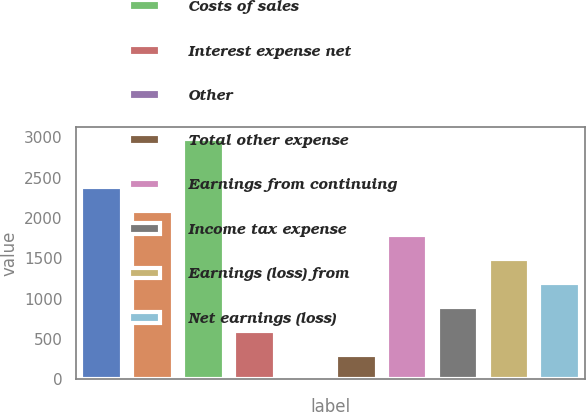Convert chart. <chart><loc_0><loc_0><loc_500><loc_500><bar_chart><fcel>Costs of product sales<fcel>Costs of services sales<fcel>Costs of sales<fcel>Interest expense net<fcel>Other<fcel>Total other expense<fcel>Earnings from continuing<fcel>Income tax expense<fcel>Earnings (loss) from<fcel>Net earnings (loss)<nl><fcel>2383<fcel>2086.5<fcel>2976<fcel>604<fcel>11<fcel>307.5<fcel>1790<fcel>900.5<fcel>1493.5<fcel>1197<nl></chart> 